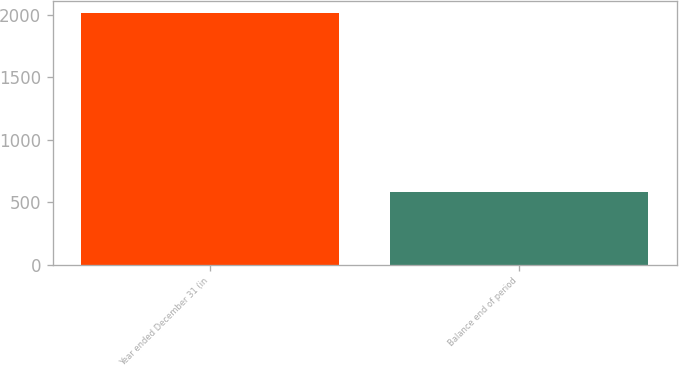<chart> <loc_0><loc_0><loc_500><loc_500><bar_chart><fcel>Year ended December 31 (in<fcel>Balance end of period<nl><fcel>2009<fcel>578<nl></chart> 